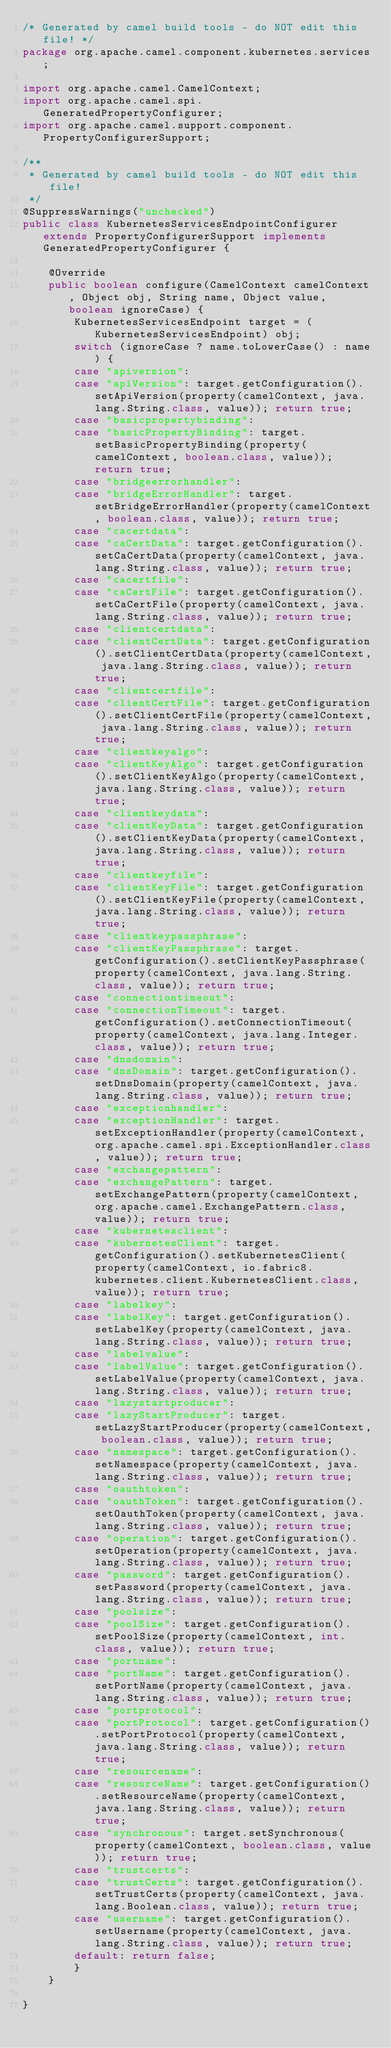<code> <loc_0><loc_0><loc_500><loc_500><_Java_>/* Generated by camel build tools - do NOT edit this file! */
package org.apache.camel.component.kubernetes.services;

import org.apache.camel.CamelContext;
import org.apache.camel.spi.GeneratedPropertyConfigurer;
import org.apache.camel.support.component.PropertyConfigurerSupport;

/**
 * Generated by camel build tools - do NOT edit this file!
 */
@SuppressWarnings("unchecked")
public class KubernetesServicesEndpointConfigurer extends PropertyConfigurerSupport implements GeneratedPropertyConfigurer {

    @Override
    public boolean configure(CamelContext camelContext, Object obj, String name, Object value, boolean ignoreCase) {
        KubernetesServicesEndpoint target = (KubernetesServicesEndpoint) obj;
        switch (ignoreCase ? name.toLowerCase() : name) {
        case "apiversion":
        case "apiVersion": target.getConfiguration().setApiVersion(property(camelContext, java.lang.String.class, value)); return true;
        case "basicpropertybinding":
        case "basicPropertyBinding": target.setBasicPropertyBinding(property(camelContext, boolean.class, value)); return true;
        case "bridgeerrorhandler":
        case "bridgeErrorHandler": target.setBridgeErrorHandler(property(camelContext, boolean.class, value)); return true;
        case "cacertdata":
        case "caCertData": target.getConfiguration().setCaCertData(property(camelContext, java.lang.String.class, value)); return true;
        case "cacertfile":
        case "caCertFile": target.getConfiguration().setCaCertFile(property(camelContext, java.lang.String.class, value)); return true;
        case "clientcertdata":
        case "clientCertData": target.getConfiguration().setClientCertData(property(camelContext, java.lang.String.class, value)); return true;
        case "clientcertfile":
        case "clientCertFile": target.getConfiguration().setClientCertFile(property(camelContext, java.lang.String.class, value)); return true;
        case "clientkeyalgo":
        case "clientKeyAlgo": target.getConfiguration().setClientKeyAlgo(property(camelContext, java.lang.String.class, value)); return true;
        case "clientkeydata":
        case "clientKeyData": target.getConfiguration().setClientKeyData(property(camelContext, java.lang.String.class, value)); return true;
        case "clientkeyfile":
        case "clientKeyFile": target.getConfiguration().setClientKeyFile(property(camelContext, java.lang.String.class, value)); return true;
        case "clientkeypassphrase":
        case "clientKeyPassphrase": target.getConfiguration().setClientKeyPassphrase(property(camelContext, java.lang.String.class, value)); return true;
        case "connectiontimeout":
        case "connectionTimeout": target.getConfiguration().setConnectionTimeout(property(camelContext, java.lang.Integer.class, value)); return true;
        case "dnsdomain":
        case "dnsDomain": target.getConfiguration().setDnsDomain(property(camelContext, java.lang.String.class, value)); return true;
        case "exceptionhandler":
        case "exceptionHandler": target.setExceptionHandler(property(camelContext, org.apache.camel.spi.ExceptionHandler.class, value)); return true;
        case "exchangepattern":
        case "exchangePattern": target.setExchangePattern(property(camelContext, org.apache.camel.ExchangePattern.class, value)); return true;
        case "kubernetesclient":
        case "kubernetesClient": target.getConfiguration().setKubernetesClient(property(camelContext, io.fabric8.kubernetes.client.KubernetesClient.class, value)); return true;
        case "labelkey":
        case "labelKey": target.getConfiguration().setLabelKey(property(camelContext, java.lang.String.class, value)); return true;
        case "labelvalue":
        case "labelValue": target.getConfiguration().setLabelValue(property(camelContext, java.lang.String.class, value)); return true;
        case "lazystartproducer":
        case "lazyStartProducer": target.setLazyStartProducer(property(camelContext, boolean.class, value)); return true;
        case "namespace": target.getConfiguration().setNamespace(property(camelContext, java.lang.String.class, value)); return true;
        case "oauthtoken":
        case "oauthToken": target.getConfiguration().setOauthToken(property(camelContext, java.lang.String.class, value)); return true;
        case "operation": target.getConfiguration().setOperation(property(camelContext, java.lang.String.class, value)); return true;
        case "password": target.getConfiguration().setPassword(property(camelContext, java.lang.String.class, value)); return true;
        case "poolsize":
        case "poolSize": target.getConfiguration().setPoolSize(property(camelContext, int.class, value)); return true;
        case "portname":
        case "portName": target.getConfiguration().setPortName(property(camelContext, java.lang.String.class, value)); return true;
        case "portprotocol":
        case "portProtocol": target.getConfiguration().setPortProtocol(property(camelContext, java.lang.String.class, value)); return true;
        case "resourcename":
        case "resourceName": target.getConfiguration().setResourceName(property(camelContext, java.lang.String.class, value)); return true;
        case "synchronous": target.setSynchronous(property(camelContext, boolean.class, value)); return true;
        case "trustcerts":
        case "trustCerts": target.getConfiguration().setTrustCerts(property(camelContext, java.lang.Boolean.class, value)); return true;
        case "username": target.getConfiguration().setUsername(property(camelContext, java.lang.String.class, value)); return true;
        default: return false;
        }
    }

}

</code> 